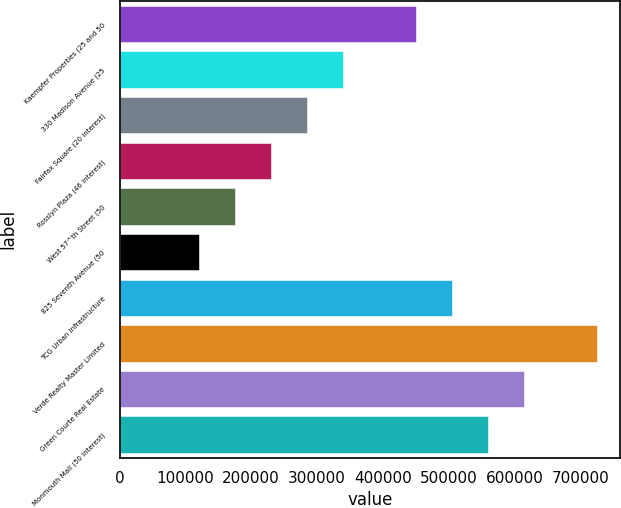Convert chart. <chart><loc_0><loc_0><loc_500><loc_500><bar_chart><fcel>Kaempfer Properties (25 and 50<fcel>330 Madison Avenue (25<fcel>Fairfax Square (20 interest)<fcel>Rosslyn Plaza (46 interest)<fcel>West 57^th Street (50<fcel>825 Seventh Avenue (50<fcel>TCG Urban Infrastructure<fcel>Verde Realty Master Limited<fcel>Green Courte Real Estate<fcel>Monmouth Mall (50 interest)<nl><fcel>449912<fcel>339984<fcel>285020<fcel>230056<fcel>175092<fcel>120128<fcel>504876<fcel>724732<fcel>614804<fcel>559840<nl></chart> 